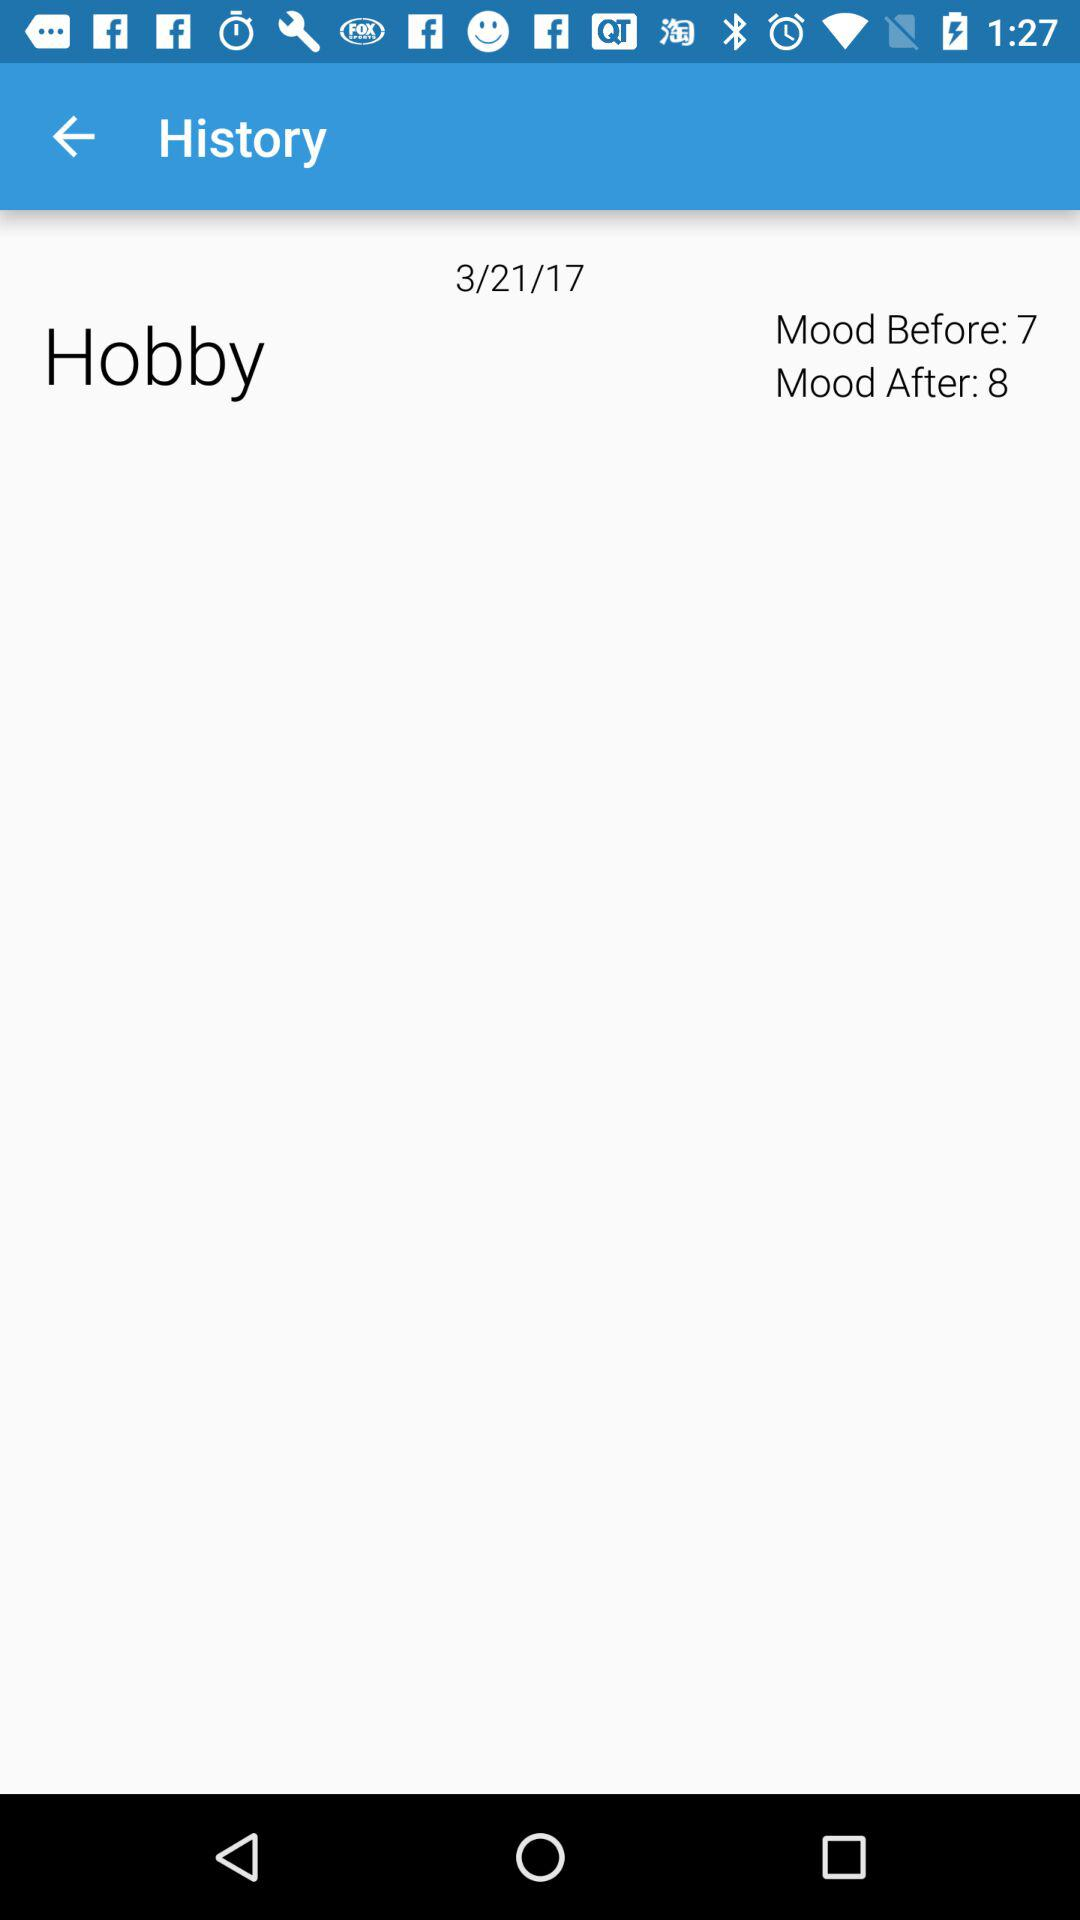How much did the mood improve?
Answer the question using a single word or phrase. 1 